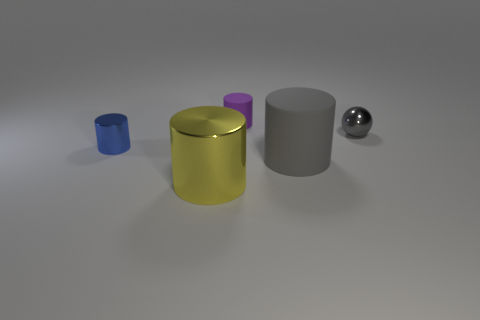Add 3 cyan metal blocks. How many objects exist? 8 Subtract all balls. How many objects are left? 4 Add 1 green matte blocks. How many green matte blocks exist? 1 Subtract 0 red cylinders. How many objects are left? 5 Subtract all gray things. Subtract all big brown spheres. How many objects are left? 3 Add 5 purple things. How many purple things are left? 6 